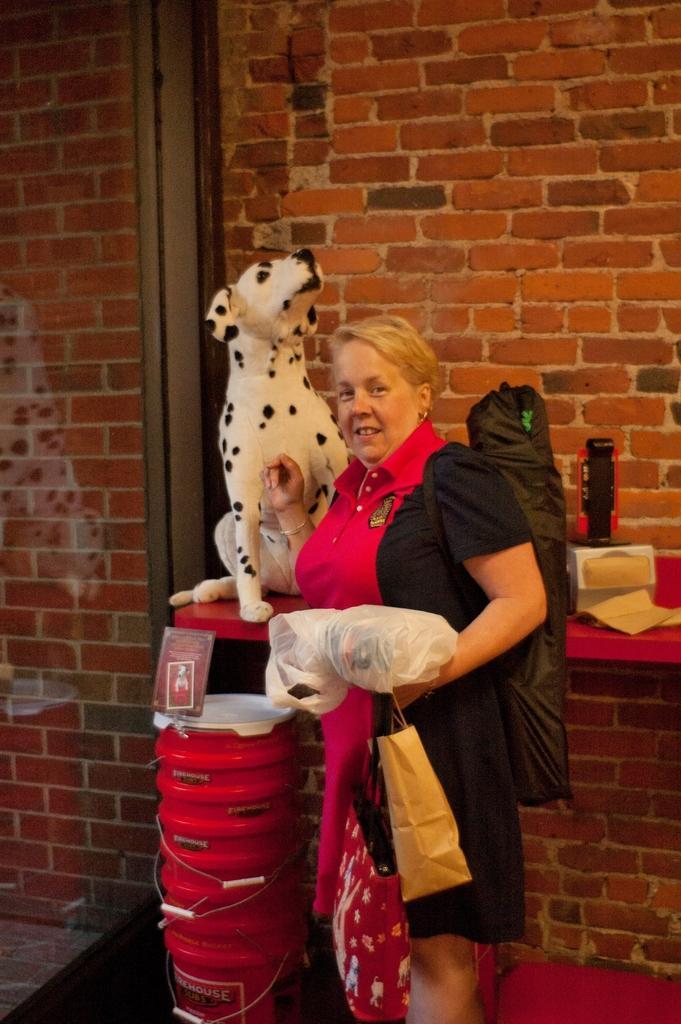Please provide a concise description of this image. This image is taken indoors. At the bottom of the image there is a floor. In the background there is a wall and there is a table with a few things on it and there is a dog on the table. In the middle of the image a woman is standing on the floor. 